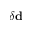Convert formula to latex. <formula><loc_0><loc_0><loc_500><loc_500>\delta { d }</formula> 